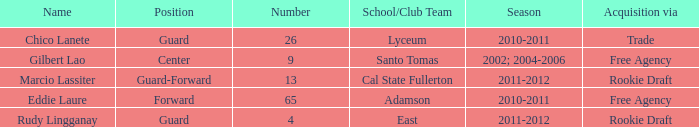I'm looking to parse the entire table for insights. Could you assist me with that? {'header': ['Name', 'Position', 'Number', 'School/Club Team', 'Season', 'Acquisition via'], 'rows': [['Chico Lanete', 'Guard', '26', 'Lyceum', '2010-2011', 'Trade'], ['Gilbert Lao', 'Center', '9', 'Santo Tomas', '2002; 2004-2006', 'Free Agency'], ['Marcio Lassiter', 'Guard-Forward', '13', 'Cal State Fullerton', '2011-2012', 'Rookie Draft'], ['Eddie Laure', 'Forward', '65', 'Adamson', '2010-2011', 'Free Agency'], ['Rudy Lingganay', 'Guard', '4', 'East', '2011-2012', 'Rookie Draft']]} Which season experienced a procurement of free agency and was greater than 9? 2010-2011. 